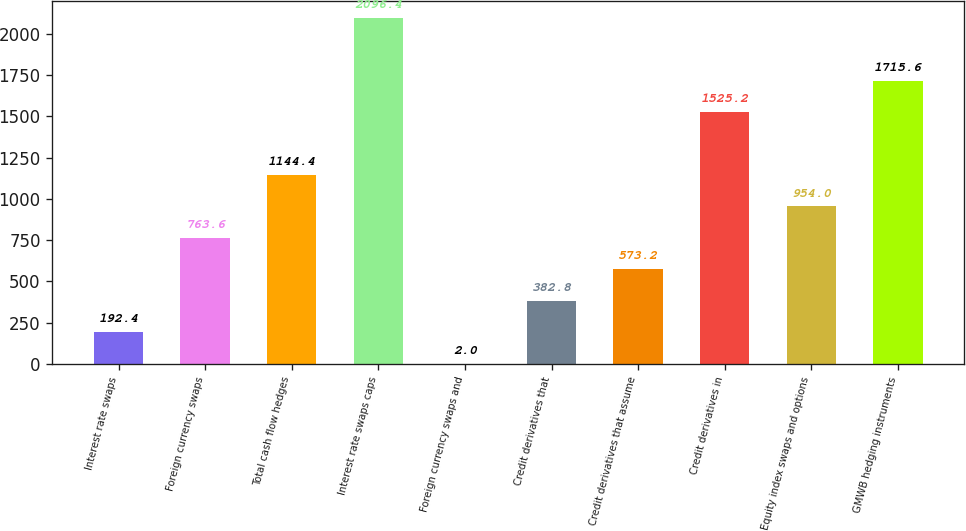Convert chart. <chart><loc_0><loc_0><loc_500><loc_500><bar_chart><fcel>Interest rate swaps<fcel>Foreign currency swaps<fcel>Total cash flow hedges<fcel>Interest rate swaps caps<fcel>Foreign currency swaps and<fcel>Credit derivatives that<fcel>Credit derivatives that assume<fcel>Credit derivatives in<fcel>Equity index swaps and options<fcel>GMWB hedging instruments<nl><fcel>192.4<fcel>763.6<fcel>1144.4<fcel>2096.4<fcel>2<fcel>382.8<fcel>573.2<fcel>1525.2<fcel>954<fcel>1715.6<nl></chart> 